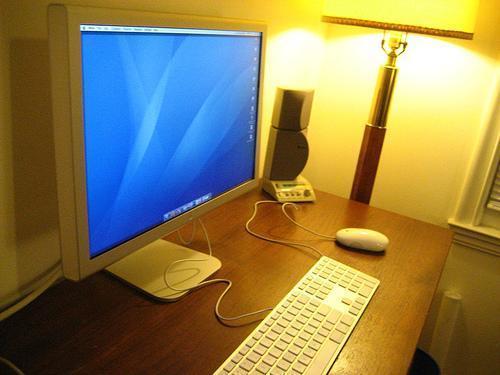How many monitors are in the photo?
Give a very brief answer. 1. 